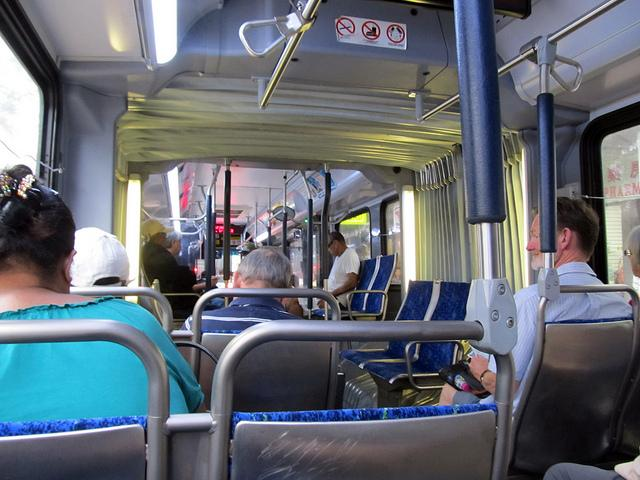What is explicitly forbidden on the bus? Please explain your reasoning. eating. There is a sign of food and a drink with a line through it, which means it is not permitted. 